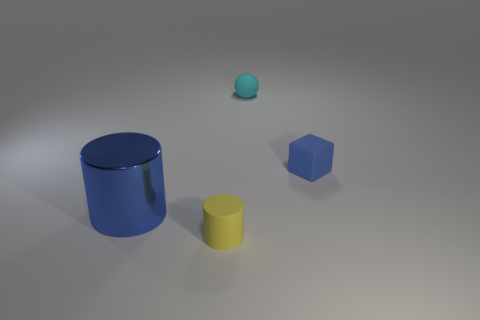What is the size of the rubber object that is the same color as the metallic object?
Offer a terse response. Small. What color is the matte cube that is the same size as the matte cylinder?
Ensure brevity in your answer.  Blue. Is the number of big blue shiny objects that are on the right side of the large blue metallic cylinder less than the number of yellow cylinders to the right of the tiny yellow matte cylinder?
Ensure brevity in your answer.  No. How many small matte things are behind the blue thing to the right of the cylinder right of the large metallic cylinder?
Your answer should be very brief. 1. The other object that is the same shape as the metallic thing is what size?
Your answer should be compact. Small. Is there any other thing that is the same size as the cyan rubber ball?
Provide a succinct answer. Yes. Are there fewer small matte balls in front of the cyan matte sphere than yellow cylinders?
Provide a short and direct response. Yes. Does the big blue shiny thing have the same shape as the small yellow object?
Provide a short and direct response. Yes. There is another matte object that is the same shape as the large thing; what is its color?
Your answer should be very brief. Yellow. What number of tiny matte blocks have the same color as the big cylinder?
Make the answer very short. 1. 